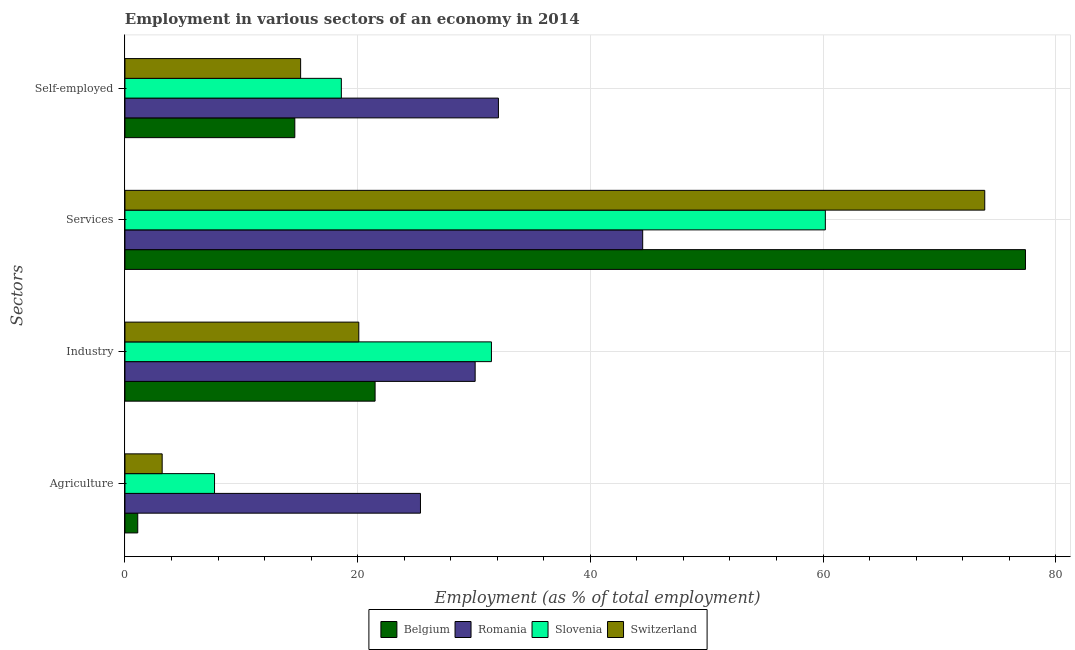Are the number of bars per tick equal to the number of legend labels?
Your answer should be very brief. Yes. Are the number of bars on each tick of the Y-axis equal?
Offer a terse response. Yes. How many bars are there on the 1st tick from the top?
Provide a succinct answer. 4. How many bars are there on the 2nd tick from the bottom?
Provide a succinct answer. 4. What is the label of the 2nd group of bars from the top?
Make the answer very short. Services. What is the percentage of workers in agriculture in Switzerland?
Your response must be concise. 3.2. Across all countries, what is the maximum percentage of workers in industry?
Give a very brief answer. 31.5. Across all countries, what is the minimum percentage of self employed workers?
Offer a terse response. 14.6. In which country was the percentage of workers in industry maximum?
Give a very brief answer. Slovenia. In which country was the percentage of workers in services minimum?
Keep it short and to the point. Romania. What is the total percentage of workers in industry in the graph?
Provide a succinct answer. 103.2. What is the difference between the percentage of workers in agriculture in Belgium and that in Slovenia?
Give a very brief answer. -6.6. What is the difference between the percentage of workers in services in Switzerland and the percentage of self employed workers in Romania?
Offer a terse response. 41.8. What is the average percentage of workers in services per country?
Keep it short and to the point. 64. What is the difference between the percentage of workers in agriculture and percentage of self employed workers in Belgium?
Your answer should be very brief. -13.5. What is the ratio of the percentage of workers in industry in Slovenia to that in Romania?
Your answer should be compact. 1.05. What is the difference between the highest and the second highest percentage of workers in services?
Provide a short and direct response. 3.5. What is the difference between the highest and the lowest percentage of workers in agriculture?
Ensure brevity in your answer.  24.3. Is the sum of the percentage of workers in industry in Switzerland and Belgium greater than the maximum percentage of workers in services across all countries?
Give a very brief answer. No. Is it the case that in every country, the sum of the percentage of workers in agriculture and percentage of self employed workers is greater than the sum of percentage of workers in services and percentage of workers in industry?
Your response must be concise. No. What does the 4th bar from the top in Agriculture represents?
Offer a very short reply. Belgium. What does the 4th bar from the bottom in Industry represents?
Offer a terse response. Switzerland. How many bars are there?
Your answer should be compact. 16. How many legend labels are there?
Keep it short and to the point. 4. What is the title of the graph?
Provide a short and direct response. Employment in various sectors of an economy in 2014. Does "Pacific island small states" appear as one of the legend labels in the graph?
Your response must be concise. No. What is the label or title of the X-axis?
Give a very brief answer. Employment (as % of total employment). What is the label or title of the Y-axis?
Ensure brevity in your answer.  Sectors. What is the Employment (as % of total employment) of Belgium in Agriculture?
Keep it short and to the point. 1.1. What is the Employment (as % of total employment) in Romania in Agriculture?
Offer a terse response. 25.4. What is the Employment (as % of total employment) in Slovenia in Agriculture?
Make the answer very short. 7.7. What is the Employment (as % of total employment) in Switzerland in Agriculture?
Make the answer very short. 3.2. What is the Employment (as % of total employment) in Belgium in Industry?
Keep it short and to the point. 21.5. What is the Employment (as % of total employment) in Romania in Industry?
Your answer should be very brief. 30.1. What is the Employment (as % of total employment) in Slovenia in Industry?
Keep it short and to the point. 31.5. What is the Employment (as % of total employment) of Switzerland in Industry?
Your answer should be very brief. 20.1. What is the Employment (as % of total employment) of Belgium in Services?
Ensure brevity in your answer.  77.4. What is the Employment (as % of total employment) of Romania in Services?
Provide a short and direct response. 44.5. What is the Employment (as % of total employment) of Slovenia in Services?
Ensure brevity in your answer.  60.2. What is the Employment (as % of total employment) of Switzerland in Services?
Offer a very short reply. 73.9. What is the Employment (as % of total employment) in Belgium in Self-employed?
Your answer should be compact. 14.6. What is the Employment (as % of total employment) of Romania in Self-employed?
Provide a short and direct response. 32.1. What is the Employment (as % of total employment) in Slovenia in Self-employed?
Give a very brief answer. 18.6. What is the Employment (as % of total employment) in Switzerland in Self-employed?
Keep it short and to the point. 15.1. Across all Sectors, what is the maximum Employment (as % of total employment) of Belgium?
Provide a short and direct response. 77.4. Across all Sectors, what is the maximum Employment (as % of total employment) in Romania?
Offer a terse response. 44.5. Across all Sectors, what is the maximum Employment (as % of total employment) in Slovenia?
Offer a very short reply. 60.2. Across all Sectors, what is the maximum Employment (as % of total employment) in Switzerland?
Offer a very short reply. 73.9. Across all Sectors, what is the minimum Employment (as % of total employment) in Belgium?
Provide a succinct answer. 1.1. Across all Sectors, what is the minimum Employment (as % of total employment) in Romania?
Provide a short and direct response. 25.4. Across all Sectors, what is the minimum Employment (as % of total employment) of Slovenia?
Your answer should be very brief. 7.7. Across all Sectors, what is the minimum Employment (as % of total employment) of Switzerland?
Give a very brief answer. 3.2. What is the total Employment (as % of total employment) in Belgium in the graph?
Ensure brevity in your answer.  114.6. What is the total Employment (as % of total employment) in Romania in the graph?
Offer a terse response. 132.1. What is the total Employment (as % of total employment) in Slovenia in the graph?
Make the answer very short. 118. What is the total Employment (as % of total employment) of Switzerland in the graph?
Provide a short and direct response. 112.3. What is the difference between the Employment (as % of total employment) in Belgium in Agriculture and that in Industry?
Your answer should be very brief. -20.4. What is the difference between the Employment (as % of total employment) in Slovenia in Agriculture and that in Industry?
Your answer should be compact. -23.8. What is the difference between the Employment (as % of total employment) of Switzerland in Agriculture and that in Industry?
Your answer should be very brief. -16.9. What is the difference between the Employment (as % of total employment) in Belgium in Agriculture and that in Services?
Provide a succinct answer. -76.3. What is the difference between the Employment (as % of total employment) of Romania in Agriculture and that in Services?
Provide a succinct answer. -19.1. What is the difference between the Employment (as % of total employment) of Slovenia in Agriculture and that in Services?
Make the answer very short. -52.5. What is the difference between the Employment (as % of total employment) in Switzerland in Agriculture and that in Services?
Provide a succinct answer. -70.7. What is the difference between the Employment (as % of total employment) of Belgium in Agriculture and that in Self-employed?
Offer a very short reply. -13.5. What is the difference between the Employment (as % of total employment) in Romania in Agriculture and that in Self-employed?
Make the answer very short. -6.7. What is the difference between the Employment (as % of total employment) of Switzerland in Agriculture and that in Self-employed?
Offer a very short reply. -11.9. What is the difference between the Employment (as % of total employment) in Belgium in Industry and that in Services?
Keep it short and to the point. -55.9. What is the difference between the Employment (as % of total employment) in Romania in Industry and that in Services?
Provide a short and direct response. -14.4. What is the difference between the Employment (as % of total employment) in Slovenia in Industry and that in Services?
Provide a short and direct response. -28.7. What is the difference between the Employment (as % of total employment) in Switzerland in Industry and that in Services?
Keep it short and to the point. -53.8. What is the difference between the Employment (as % of total employment) in Romania in Industry and that in Self-employed?
Offer a terse response. -2. What is the difference between the Employment (as % of total employment) of Switzerland in Industry and that in Self-employed?
Your response must be concise. 5. What is the difference between the Employment (as % of total employment) of Belgium in Services and that in Self-employed?
Ensure brevity in your answer.  62.8. What is the difference between the Employment (as % of total employment) of Slovenia in Services and that in Self-employed?
Offer a terse response. 41.6. What is the difference between the Employment (as % of total employment) of Switzerland in Services and that in Self-employed?
Your answer should be very brief. 58.8. What is the difference between the Employment (as % of total employment) in Belgium in Agriculture and the Employment (as % of total employment) in Slovenia in Industry?
Your answer should be very brief. -30.4. What is the difference between the Employment (as % of total employment) in Belgium in Agriculture and the Employment (as % of total employment) in Switzerland in Industry?
Offer a terse response. -19. What is the difference between the Employment (as % of total employment) in Romania in Agriculture and the Employment (as % of total employment) in Slovenia in Industry?
Offer a very short reply. -6.1. What is the difference between the Employment (as % of total employment) in Belgium in Agriculture and the Employment (as % of total employment) in Romania in Services?
Offer a very short reply. -43.4. What is the difference between the Employment (as % of total employment) of Belgium in Agriculture and the Employment (as % of total employment) of Slovenia in Services?
Your answer should be compact. -59.1. What is the difference between the Employment (as % of total employment) of Belgium in Agriculture and the Employment (as % of total employment) of Switzerland in Services?
Offer a very short reply. -72.8. What is the difference between the Employment (as % of total employment) in Romania in Agriculture and the Employment (as % of total employment) in Slovenia in Services?
Make the answer very short. -34.8. What is the difference between the Employment (as % of total employment) of Romania in Agriculture and the Employment (as % of total employment) of Switzerland in Services?
Provide a succinct answer. -48.5. What is the difference between the Employment (as % of total employment) in Slovenia in Agriculture and the Employment (as % of total employment) in Switzerland in Services?
Keep it short and to the point. -66.2. What is the difference between the Employment (as % of total employment) in Belgium in Agriculture and the Employment (as % of total employment) in Romania in Self-employed?
Provide a succinct answer. -31. What is the difference between the Employment (as % of total employment) of Belgium in Agriculture and the Employment (as % of total employment) of Slovenia in Self-employed?
Provide a succinct answer. -17.5. What is the difference between the Employment (as % of total employment) of Romania in Agriculture and the Employment (as % of total employment) of Slovenia in Self-employed?
Keep it short and to the point. 6.8. What is the difference between the Employment (as % of total employment) in Romania in Agriculture and the Employment (as % of total employment) in Switzerland in Self-employed?
Offer a terse response. 10.3. What is the difference between the Employment (as % of total employment) in Belgium in Industry and the Employment (as % of total employment) in Slovenia in Services?
Offer a terse response. -38.7. What is the difference between the Employment (as % of total employment) in Belgium in Industry and the Employment (as % of total employment) in Switzerland in Services?
Provide a succinct answer. -52.4. What is the difference between the Employment (as % of total employment) in Romania in Industry and the Employment (as % of total employment) in Slovenia in Services?
Make the answer very short. -30.1. What is the difference between the Employment (as % of total employment) of Romania in Industry and the Employment (as % of total employment) of Switzerland in Services?
Keep it short and to the point. -43.8. What is the difference between the Employment (as % of total employment) of Slovenia in Industry and the Employment (as % of total employment) of Switzerland in Services?
Provide a short and direct response. -42.4. What is the difference between the Employment (as % of total employment) of Belgium in Industry and the Employment (as % of total employment) of Romania in Self-employed?
Provide a short and direct response. -10.6. What is the difference between the Employment (as % of total employment) in Belgium in Industry and the Employment (as % of total employment) in Switzerland in Self-employed?
Make the answer very short. 6.4. What is the difference between the Employment (as % of total employment) of Romania in Industry and the Employment (as % of total employment) of Slovenia in Self-employed?
Provide a short and direct response. 11.5. What is the difference between the Employment (as % of total employment) in Belgium in Services and the Employment (as % of total employment) in Romania in Self-employed?
Provide a short and direct response. 45.3. What is the difference between the Employment (as % of total employment) of Belgium in Services and the Employment (as % of total employment) of Slovenia in Self-employed?
Your answer should be compact. 58.8. What is the difference between the Employment (as % of total employment) of Belgium in Services and the Employment (as % of total employment) of Switzerland in Self-employed?
Keep it short and to the point. 62.3. What is the difference between the Employment (as % of total employment) of Romania in Services and the Employment (as % of total employment) of Slovenia in Self-employed?
Provide a short and direct response. 25.9. What is the difference between the Employment (as % of total employment) of Romania in Services and the Employment (as % of total employment) of Switzerland in Self-employed?
Your response must be concise. 29.4. What is the difference between the Employment (as % of total employment) in Slovenia in Services and the Employment (as % of total employment) in Switzerland in Self-employed?
Your answer should be compact. 45.1. What is the average Employment (as % of total employment) in Belgium per Sectors?
Provide a succinct answer. 28.65. What is the average Employment (as % of total employment) of Romania per Sectors?
Offer a very short reply. 33.02. What is the average Employment (as % of total employment) in Slovenia per Sectors?
Offer a very short reply. 29.5. What is the average Employment (as % of total employment) in Switzerland per Sectors?
Your response must be concise. 28.07. What is the difference between the Employment (as % of total employment) of Belgium and Employment (as % of total employment) of Romania in Agriculture?
Keep it short and to the point. -24.3. What is the difference between the Employment (as % of total employment) of Belgium and Employment (as % of total employment) of Slovenia in Agriculture?
Keep it short and to the point. -6.6. What is the difference between the Employment (as % of total employment) of Romania and Employment (as % of total employment) of Slovenia in Agriculture?
Offer a terse response. 17.7. What is the difference between the Employment (as % of total employment) of Slovenia and Employment (as % of total employment) of Switzerland in Agriculture?
Your response must be concise. 4.5. What is the difference between the Employment (as % of total employment) of Belgium and Employment (as % of total employment) of Romania in Industry?
Your answer should be very brief. -8.6. What is the difference between the Employment (as % of total employment) in Belgium and Employment (as % of total employment) in Switzerland in Industry?
Ensure brevity in your answer.  1.4. What is the difference between the Employment (as % of total employment) in Romania and Employment (as % of total employment) in Slovenia in Industry?
Make the answer very short. -1.4. What is the difference between the Employment (as % of total employment) of Romania and Employment (as % of total employment) of Switzerland in Industry?
Your answer should be compact. 10. What is the difference between the Employment (as % of total employment) of Belgium and Employment (as % of total employment) of Romania in Services?
Ensure brevity in your answer.  32.9. What is the difference between the Employment (as % of total employment) of Belgium and Employment (as % of total employment) of Slovenia in Services?
Your response must be concise. 17.2. What is the difference between the Employment (as % of total employment) of Romania and Employment (as % of total employment) of Slovenia in Services?
Give a very brief answer. -15.7. What is the difference between the Employment (as % of total employment) of Romania and Employment (as % of total employment) of Switzerland in Services?
Your answer should be very brief. -29.4. What is the difference between the Employment (as % of total employment) of Slovenia and Employment (as % of total employment) of Switzerland in Services?
Your response must be concise. -13.7. What is the difference between the Employment (as % of total employment) in Belgium and Employment (as % of total employment) in Romania in Self-employed?
Your answer should be very brief. -17.5. What is the difference between the Employment (as % of total employment) in Belgium and Employment (as % of total employment) in Slovenia in Self-employed?
Ensure brevity in your answer.  -4. What is the difference between the Employment (as % of total employment) in Romania and Employment (as % of total employment) in Slovenia in Self-employed?
Offer a terse response. 13.5. What is the difference between the Employment (as % of total employment) of Slovenia and Employment (as % of total employment) of Switzerland in Self-employed?
Provide a short and direct response. 3.5. What is the ratio of the Employment (as % of total employment) in Belgium in Agriculture to that in Industry?
Offer a terse response. 0.05. What is the ratio of the Employment (as % of total employment) in Romania in Agriculture to that in Industry?
Provide a succinct answer. 0.84. What is the ratio of the Employment (as % of total employment) in Slovenia in Agriculture to that in Industry?
Offer a very short reply. 0.24. What is the ratio of the Employment (as % of total employment) of Switzerland in Agriculture to that in Industry?
Your answer should be very brief. 0.16. What is the ratio of the Employment (as % of total employment) in Belgium in Agriculture to that in Services?
Provide a short and direct response. 0.01. What is the ratio of the Employment (as % of total employment) of Romania in Agriculture to that in Services?
Provide a short and direct response. 0.57. What is the ratio of the Employment (as % of total employment) of Slovenia in Agriculture to that in Services?
Ensure brevity in your answer.  0.13. What is the ratio of the Employment (as % of total employment) in Switzerland in Agriculture to that in Services?
Provide a succinct answer. 0.04. What is the ratio of the Employment (as % of total employment) of Belgium in Agriculture to that in Self-employed?
Your answer should be very brief. 0.08. What is the ratio of the Employment (as % of total employment) in Romania in Agriculture to that in Self-employed?
Offer a terse response. 0.79. What is the ratio of the Employment (as % of total employment) in Slovenia in Agriculture to that in Self-employed?
Offer a terse response. 0.41. What is the ratio of the Employment (as % of total employment) of Switzerland in Agriculture to that in Self-employed?
Provide a succinct answer. 0.21. What is the ratio of the Employment (as % of total employment) of Belgium in Industry to that in Services?
Give a very brief answer. 0.28. What is the ratio of the Employment (as % of total employment) of Romania in Industry to that in Services?
Provide a succinct answer. 0.68. What is the ratio of the Employment (as % of total employment) of Slovenia in Industry to that in Services?
Give a very brief answer. 0.52. What is the ratio of the Employment (as % of total employment) of Switzerland in Industry to that in Services?
Offer a terse response. 0.27. What is the ratio of the Employment (as % of total employment) of Belgium in Industry to that in Self-employed?
Give a very brief answer. 1.47. What is the ratio of the Employment (as % of total employment) in Romania in Industry to that in Self-employed?
Keep it short and to the point. 0.94. What is the ratio of the Employment (as % of total employment) in Slovenia in Industry to that in Self-employed?
Keep it short and to the point. 1.69. What is the ratio of the Employment (as % of total employment) of Switzerland in Industry to that in Self-employed?
Offer a very short reply. 1.33. What is the ratio of the Employment (as % of total employment) in Belgium in Services to that in Self-employed?
Your answer should be compact. 5.3. What is the ratio of the Employment (as % of total employment) in Romania in Services to that in Self-employed?
Your answer should be compact. 1.39. What is the ratio of the Employment (as % of total employment) in Slovenia in Services to that in Self-employed?
Your answer should be very brief. 3.24. What is the ratio of the Employment (as % of total employment) of Switzerland in Services to that in Self-employed?
Ensure brevity in your answer.  4.89. What is the difference between the highest and the second highest Employment (as % of total employment) in Belgium?
Provide a short and direct response. 55.9. What is the difference between the highest and the second highest Employment (as % of total employment) of Romania?
Make the answer very short. 12.4. What is the difference between the highest and the second highest Employment (as % of total employment) in Slovenia?
Make the answer very short. 28.7. What is the difference between the highest and the second highest Employment (as % of total employment) in Switzerland?
Your answer should be compact. 53.8. What is the difference between the highest and the lowest Employment (as % of total employment) in Belgium?
Give a very brief answer. 76.3. What is the difference between the highest and the lowest Employment (as % of total employment) of Slovenia?
Your answer should be compact. 52.5. What is the difference between the highest and the lowest Employment (as % of total employment) in Switzerland?
Provide a succinct answer. 70.7. 